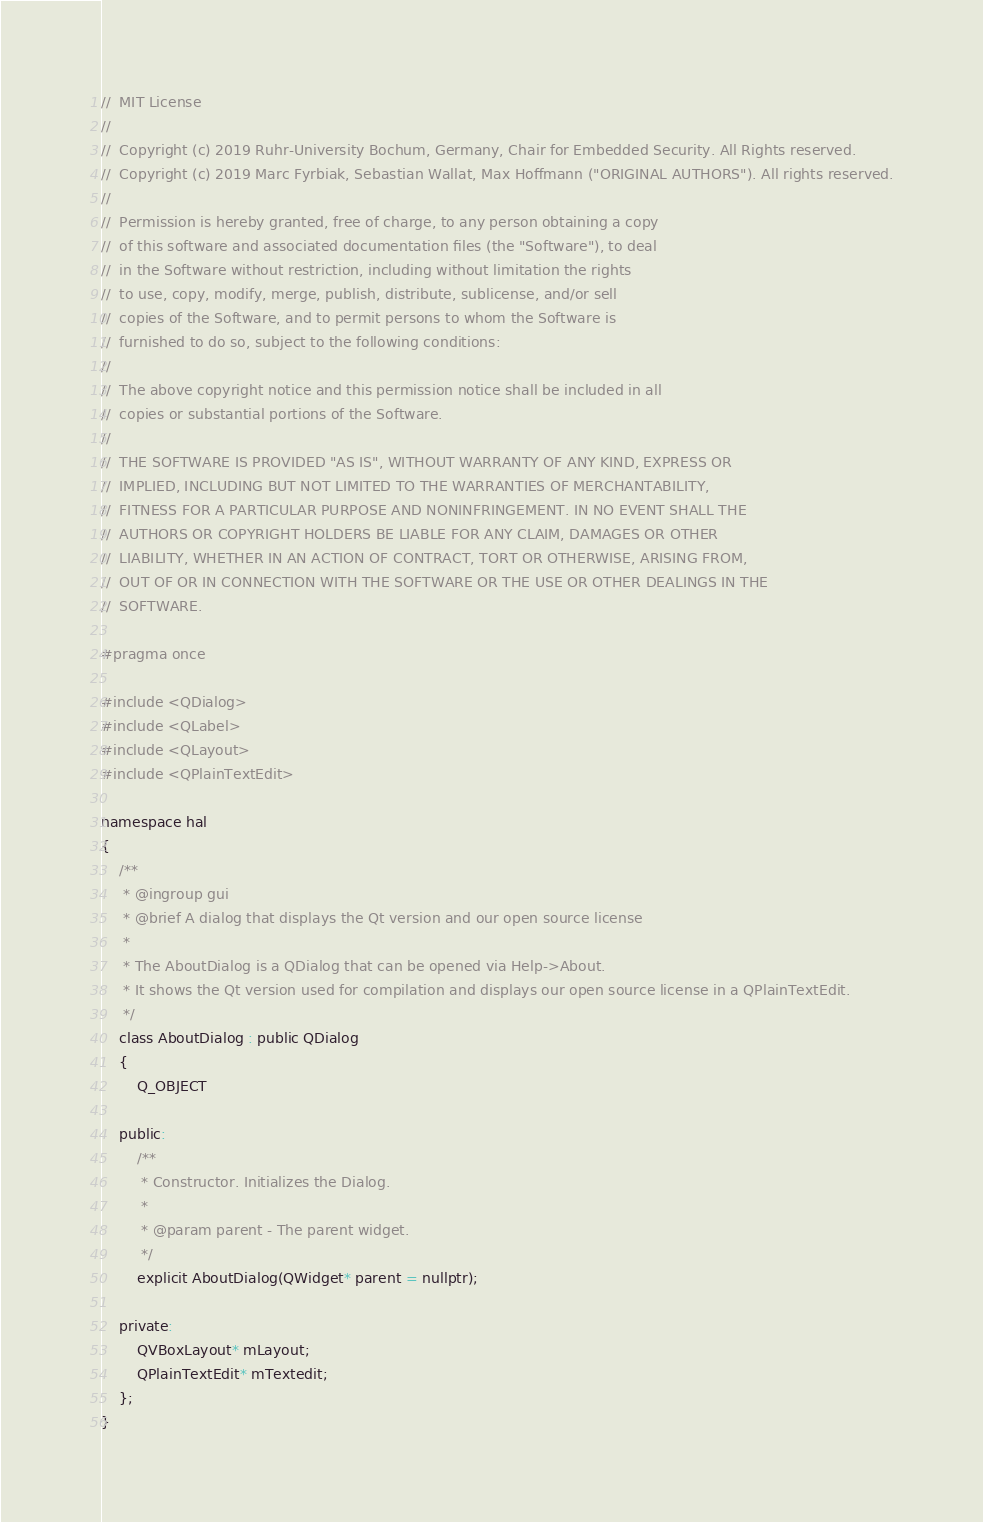<code> <loc_0><loc_0><loc_500><loc_500><_C_>//  MIT License
//
//  Copyright (c) 2019 Ruhr-University Bochum, Germany, Chair for Embedded Security. All Rights reserved.
//  Copyright (c) 2019 Marc Fyrbiak, Sebastian Wallat, Max Hoffmann ("ORIGINAL AUTHORS"). All rights reserved.
//
//  Permission is hereby granted, free of charge, to any person obtaining a copy
//  of this software and associated documentation files (the "Software"), to deal
//  in the Software without restriction, including without limitation the rights
//  to use, copy, modify, merge, publish, distribute, sublicense, and/or sell
//  copies of the Software, and to permit persons to whom the Software is
//  furnished to do so, subject to the following conditions:
//
//  The above copyright notice and this permission notice shall be included in all
//  copies or substantial portions of the Software.
//
//  THE SOFTWARE IS PROVIDED "AS IS", WITHOUT WARRANTY OF ANY KIND, EXPRESS OR
//  IMPLIED, INCLUDING BUT NOT LIMITED TO THE WARRANTIES OF MERCHANTABILITY,
//  FITNESS FOR A PARTICULAR PURPOSE AND NONINFRINGEMENT. IN NO EVENT SHALL THE
//  AUTHORS OR COPYRIGHT HOLDERS BE LIABLE FOR ANY CLAIM, DAMAGES OR OTHER
//  LIABILITY, WHETHER IN AN ACTION OF CONTRACT, TORT OR OTHERWISE, ARISING FROM,
//  OUT OF OR IN CONNECTION WITH THE SOFTWARE OR THE USE OR OTHER DEALINGS IN THE
//  SOFTWARE.

#pragma once

#include <QDialog>
#include <QLabel>
#include <QLayout>
#include <QPlainTextEdit>

namespace hal
{
    /**
     * @ingroup gui
     * @brief A dialog that displays the Qt version and our open source license
     *
     * The AboutDialog is a QDialog that can be opened via Help->About.
     * It shows the Qt version used for compilation and displays our open source license in a QPlainTextEdit.
     */
    class AboutDialog : public QDialog
    {
        Q_OBJECT

    public:
        /**
         * Constructor. Initializes the Dialog.
         *
         * @param parent - The parent widget.
         */
        explicit AboutDialog(QWidget* parent = nullptr);

    private:
        QVBoxLayout* mLayout;
        QPlainTextEdit* mTextedit;
    };
}

</code> 